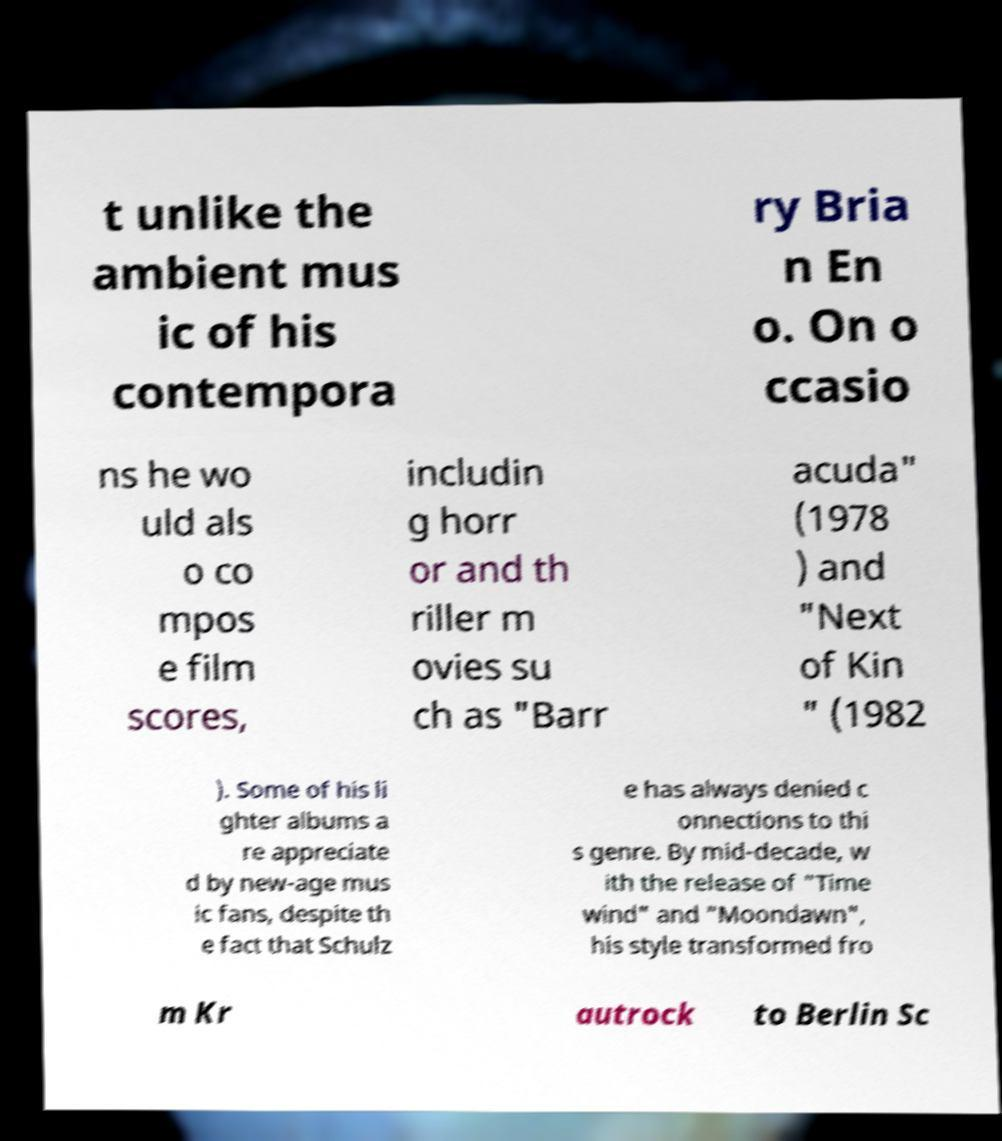Can you read and provide the text displayed in the image?This photo seems to have some interesting text. Can you extract and type it out for me? t unlike the ambient mus ic of his contempora ry Bria n En o. On o ccasio ns he wo uld als o co mpos e film scores, includin g horr or and th riller m ovies su ch as "Barr acuda" (1978 ) and "Next of Kin " (1982 ). Some of his li ghter albums a re appreciate d by new-age mus ic fans, despite th e fact that Schulz e has always denied c onnections to thi s genre. By mid-decade, w ith the release of "Time wind" and "Moondawn", his style transformed fro m Kr autrock to Berlin Sc 